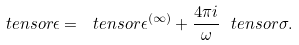<formula> <loc_0><loc_0><loc_500><loc_500>\ t e n s o r { \epsilon } = \ t e n s o r { \epsilon } ^ { ( \infty ) } + \frac { 4 \pi i } { \omega } \ t e n s o r { \sigma } .</formula> 